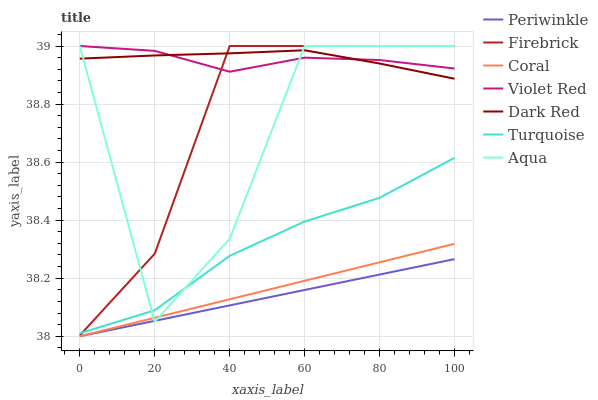Does Periwinkle have the minimum area under the curve?
Answer yes or no. Yes. Does Dark Red have the maximum area under the curve?
Answer yes or no. Yes. Does Firebrick have the minimum area under the curve?
Answer yes or no. No. Does Firebrick have the maximum area under the curve?
Answer yes or no. No. Is Periwinkle the smoothest?
Answer yes or no. Yes. Is Aqua the roughest?
Answer yes or no. Yes. Is Dark Red the smoothest?
Answer yes or no. No. Is Dark Red the roughest?
Answer yes or no. No. Does Periwinkle have the lowest value?
Answer yes or no. Yes. Does Dark Red have the lowest value?
Answer yes or no. No. Does Aqua have the highest value?
Answer yes or no. Yes. Does Dark Red have the highest value?
Answer yes or no. No. Is Coral less than Firebrick?
Answer yes or no. Yes. Is Dark Red greater than Periwinkle?
Answer yes or no. Yes. Does Aqua intersect Turquoise?
Answer yes or no. Yes. Is Aqua less than Turquoise?
Answer yes or no. No. Is Aqua greater than Turquoise?
Answer yes or no. No. Does Coral intersect Firebrick?
Answer yes or no. No. 